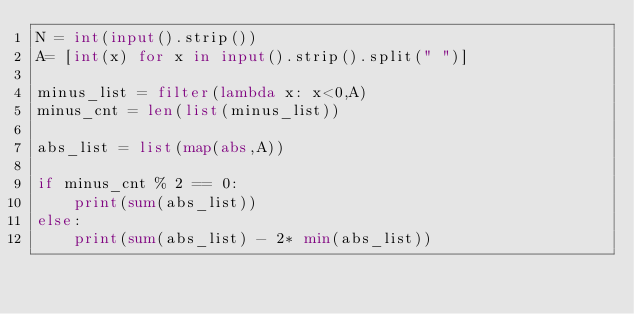Convert code to text. <code><loc_0><loc_0><loc_500><loc_500><_Python_>N = int(input().strip())
A= [int(x) for x in input().strip().split(" ")]

minus_list = filter(lambda x: x<0,A)
minus_cnt = len(list(minus_list))

abs_list = list(map(abs,A))

if minus_cnt % 2 == 0:
    print(sum(abs_list))
else:
    print(sum(abs_list) - 2* min(abs_list))
</code> 